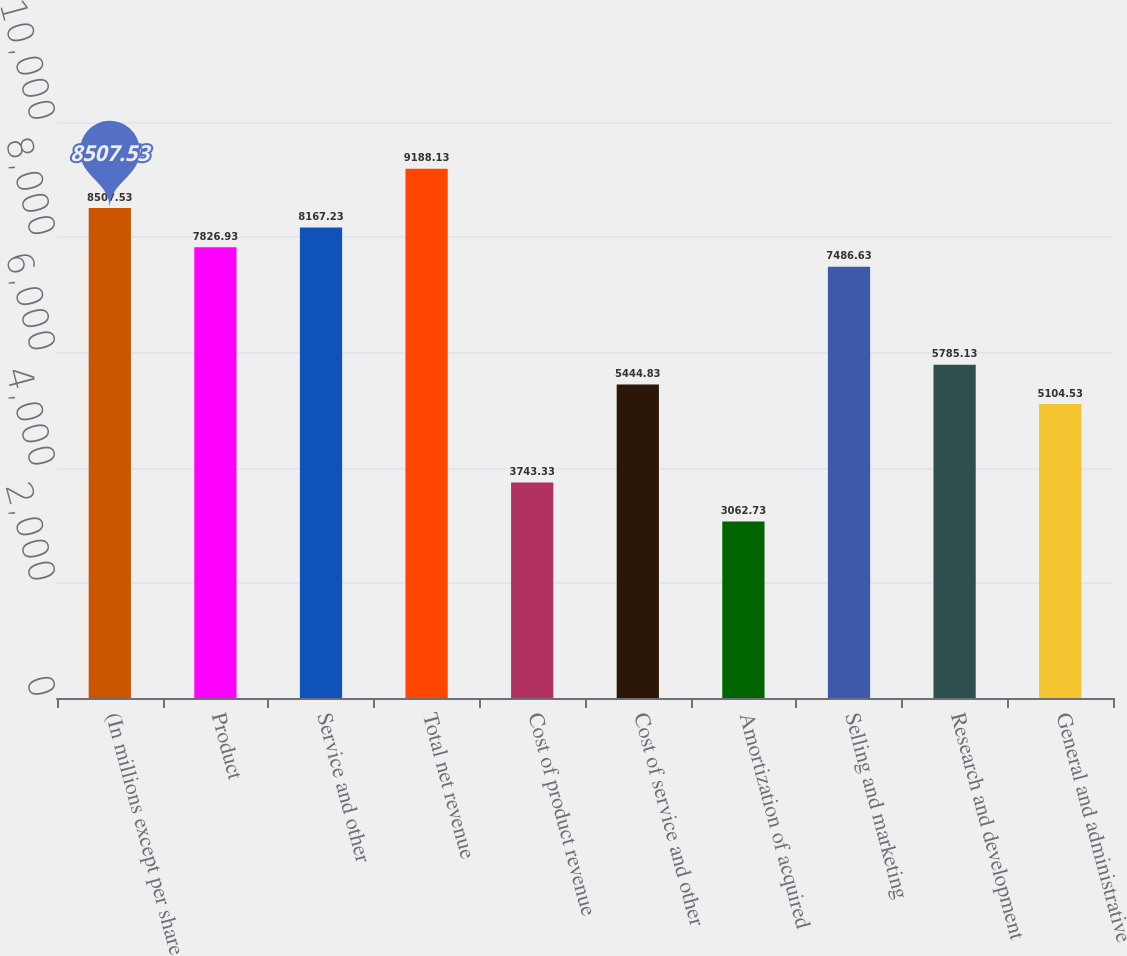Convert chart. <chart><loc_0><loc_0><loc_500><loc_500><bar_chart><fcel>(In millions except per share<fcel>Product<fcel>Service and other<fcel>Total net revenue<fcel>Cost of product revenue<fcel>Cost of service and other<fcel>Amortization of acquired<fcel>Selling and marketing<fcel>Research and development<fcel>General and administrative<nl><fcel>8507.53<fcel>7826.93<fcel>8167.23<fcel>9188.13<fcel>3743.33<fcel>5444.83<fcel>3062.73<fcel>7486.63<fcel>5785.13<fcel>5104.53<nl></chart> 